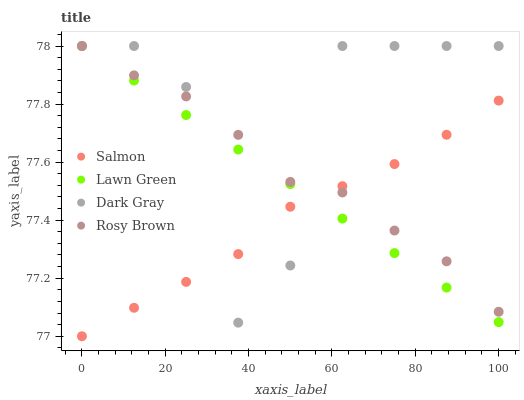Does Salmon have the minimum area under the curve?
Answer yes or no. Yes. Does Dark Gray have the maximum area under the curve?
Answer yes or no. Yes. Does Lawn Green have the minimum area under the curve?
Answer yes or no. No. Does Lawn Green have the maximum area under the curve?
Answer yes or no. No. Is Lawn Green the smoothest?
Answer yes or no. Yes. Is Dark Gray the roughest?
Answer yes or no. Yes. Is Rosy Brown the smoothest?
Answer yes or no. No. Is Rosy Brown the roughest?
Answer yes or no. No. Does Salmon have the lowest value?
Answer yes or no. Yes. Does Lawn Green have the lowest value?
Answer yes or no. No. Does Rosy Brown have the highest value?
Answer yes or no. Yes. Does Salmon have the highest value?
Answer yes or no. No. Does Lawn Green intersect Dark Gray?
Answer yes or no. Yes. Is Lawn Green less than Dark Gray?
Answer yes or no. No. Is Lawn Green greater than Dark Gray?
Answer yes or no. No. 